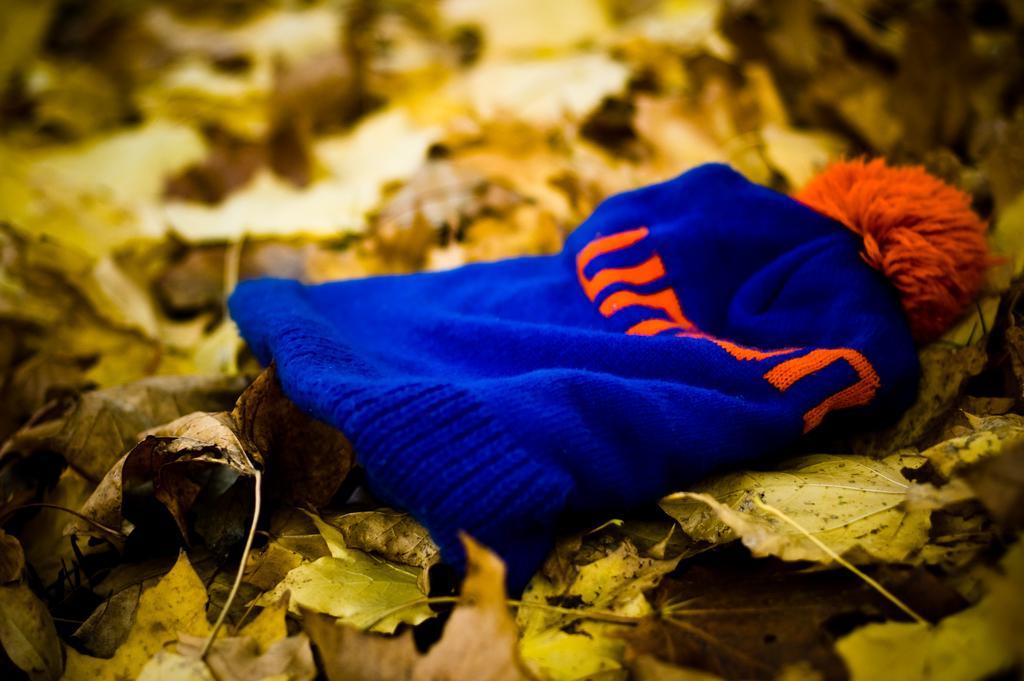Describe this image in one or two sentences. In this picture there is a blue cap which has something written on it is on yellow color leaves and there are few other leaves beside it. 